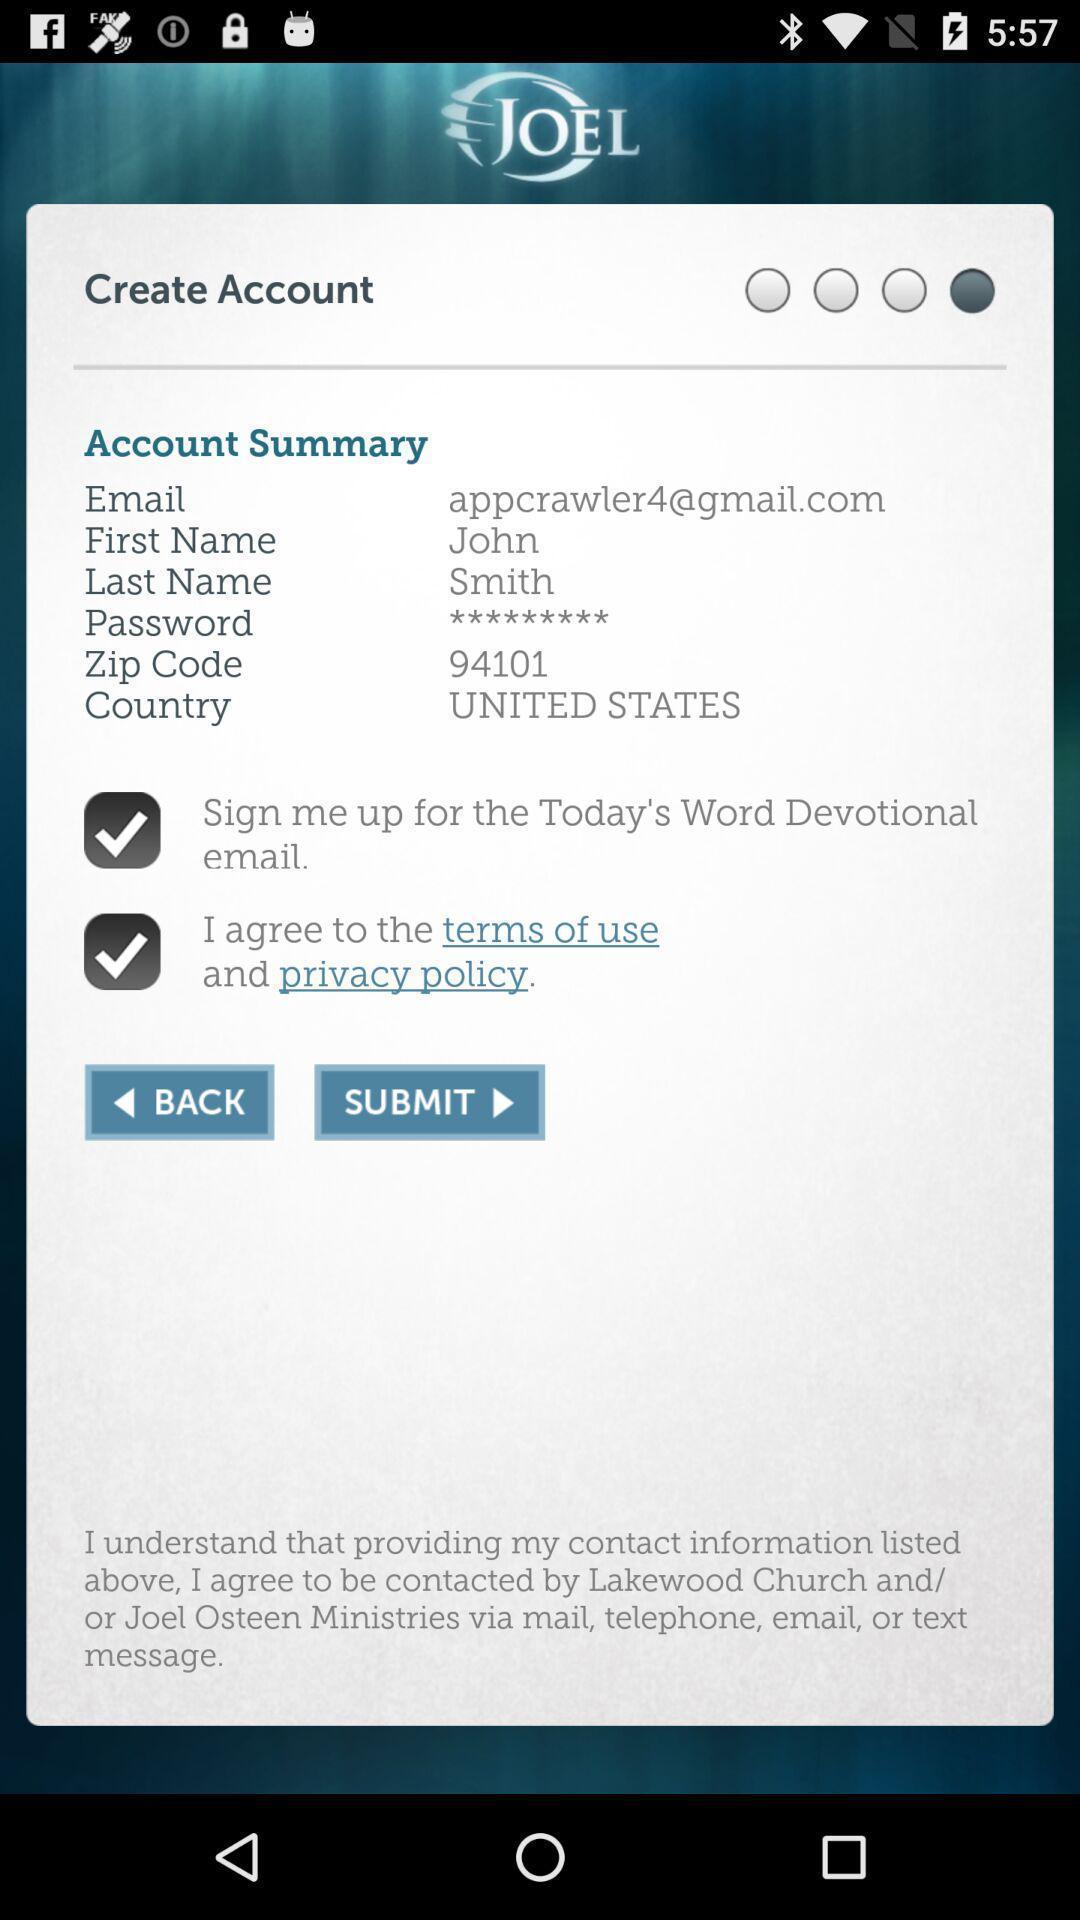Summarize the main components in this picture. Screen displaying account summary with sign in option. 